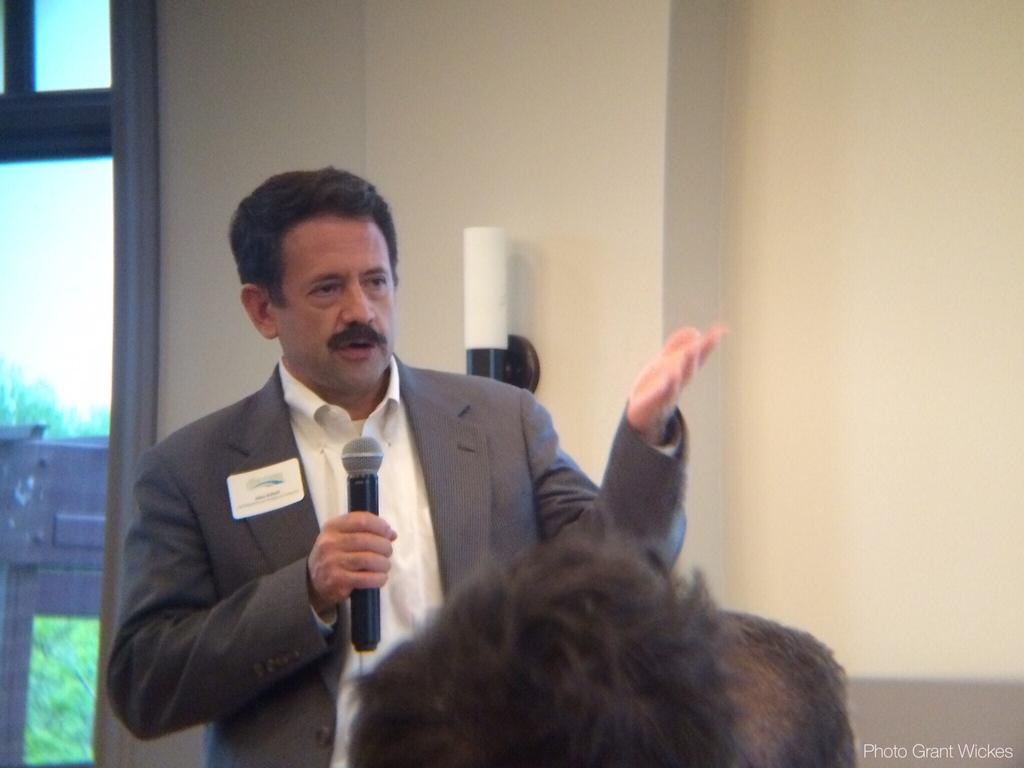What is the person in the image wearing? The person in the image is wearing a suit. What is the person doing in the image? The person is standing and speaking in front of a microphone. Are there any other people present in the image? Yes, there are other people in front of the person. How many frogs can be seen in the image? There are no frogs present in the image. 